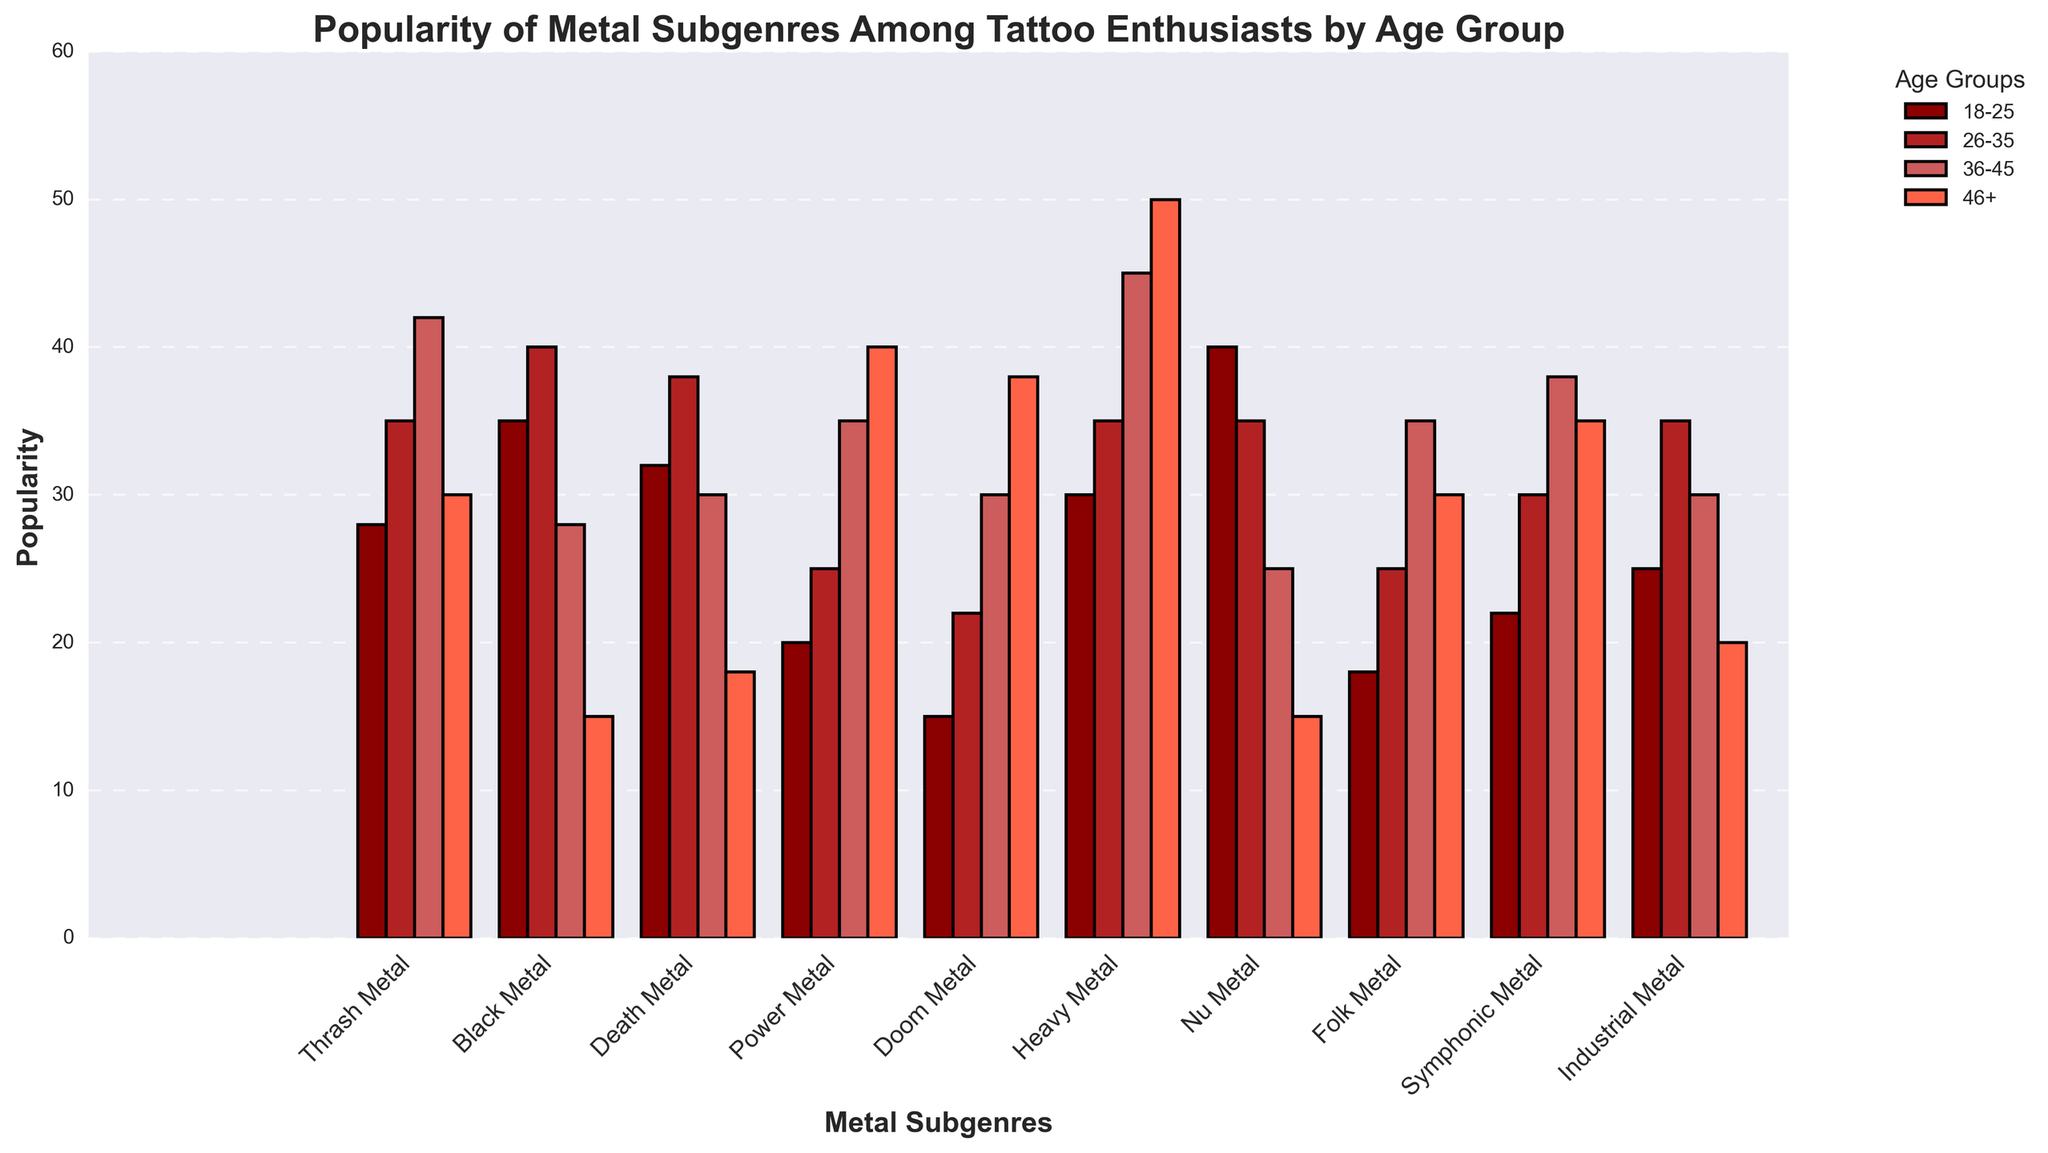Which age group finds Heavy Metal most popular? The bar height for Heavy Metal in the far right section is the highest for the 46+ age group.
Answer: 46+ What is the least popular subgenre among the 18-25 age group? Compare the bar heights for the 18-25 age group. Doom Metal has the shortest bar.
Answer: Doom Metal Which two subgenres are equally popular among the 26-35 age group? Thrash Metal and Nu Metal have bars of equal height in the 26-35 age group.
Answer: Thrash Metal and Nu Metal How does the popularity of Death Metal compare between the 18-25 and 46+ age groups? Death Metal's bar height is higher for the 18-25 age group when compared to the 46+ age group.
Answer: 18-25 group prefers more Which age group has the most balanced preference among the subgenres? Examine the differences in bar heights for each age group. The 26-35 age group has the smallest variations across subgenres.
Answer: 26-35 What is the combined popularity of Black Metal and Doom Metal among the 26-35 age group? Add the bar heights for Black Metal (40) and Doom Metal (22) in the 26-35 age group.
Answer: 62 What subgenre has the greatest increase in popularity from the 18-25 age group to the 46+ age group? Compare the differences in bar heights between the 18-25 and 46+ age groups. Power Metal shows the most significant increase.
Answer: Power Metal Which subgenre is preferred more by younger enthusiasts (18-25) compared to older enthusiasts (46+)? Look for subgenres where the 18-25 bar height is significantly higher than the 46+ bar height. Nu Metal is preferred more by younger enthusiasts.
Answer: Nu Metal Are there any subgenres that show a steady increase in popularity with age? Review subgenres where bar heights consistently increase across age groups. Heavy Metal displays this trend.
Answer: Heavy Metal Which subgenre shows the least variation in popularity across all age groups? Observe subgenres with relatively equal bar heights. Folk Metal shows the least variation.
Answer: Folk Metal 